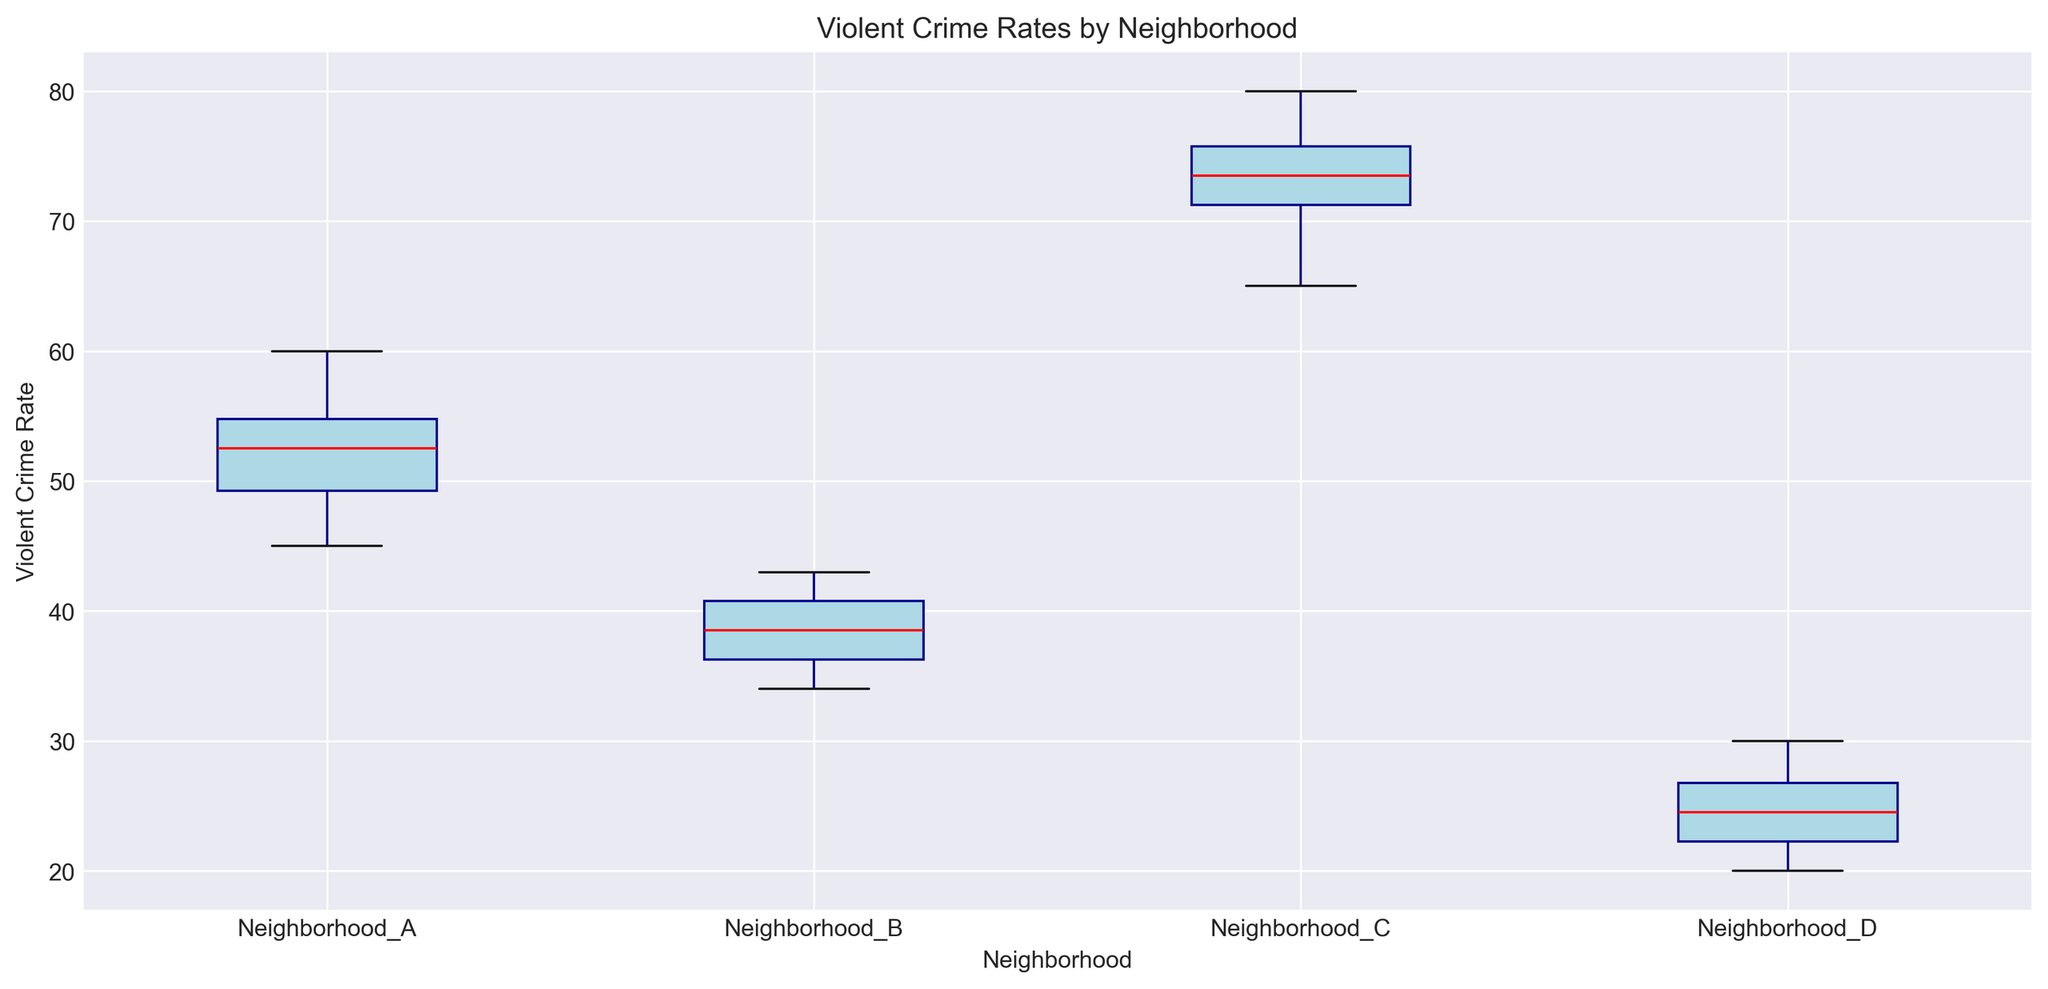What neighborhood has the highest median violent crime rate? The figure shows box plots for each neighborhood, with the median represented by a red line inside the box. Neighborhood C has the highest median line compared to others.
Answer: Neighborhood C Which neighborhood has the lowest minimum violent crime rate? The minimum rate is represented by the bottom whisker of the box plot. Neighborhood D has the lowest minimum rate compared to the others.
Answer: Neighborhood D What is the range of violent crime rates in Neighborhood A? The range is calculated by subtracting the minimum value from the maximum value in the box plot. For Neighborhood A, the minimum is 45 and the maximum is 60, so 60 - 45 = 15.
Answer: 15 Compare the medians of Neighborhood B and Neighborhood D. Which is higher? The median is shown as the red line inside the box. Comparing Neighborhood B and D, the red line is higher for Neighborhood B.
Answer: Neighborhood B How much higher is the maximum violent crime rate in Neighborhood C compared to Neighborhood B? The maximum rate is represented by the top whisker. Neighborhood C's maximum is 80, and Neighborhood B's maximum is 43. The difference is 80 - 43 = 37.
Answer: 37 Between which neighborhoods is the interquartile range (IQR) smallest? The IQR is the height of the box itself. Comparing all neighborhoods visually, Neighborhood D has the shortest box, indicating the smallest IQR.
Answer: Neighborhood D Which neighborhood shows the most spread in violent crime rates? The spread is indicated by the whiskers and the outliers. Neighborhood C has the widest spread from the minimum to maximum values.
Answer: Neighborhood C Are there any outliers visible in the box plots? Outliers are usually shown as individual points outside the whiskers. By observing the box plots, there are no individual points beyond the whiskers, indicating no visible outliers.
Answer: No How does the median violent crime rate in Neighborhood A compare to that in Neighborhood C? The median is shown as the red line. Comparing the two, Neighborhood A's median is lower than Neighborhood C's median.
Answer: Lower 